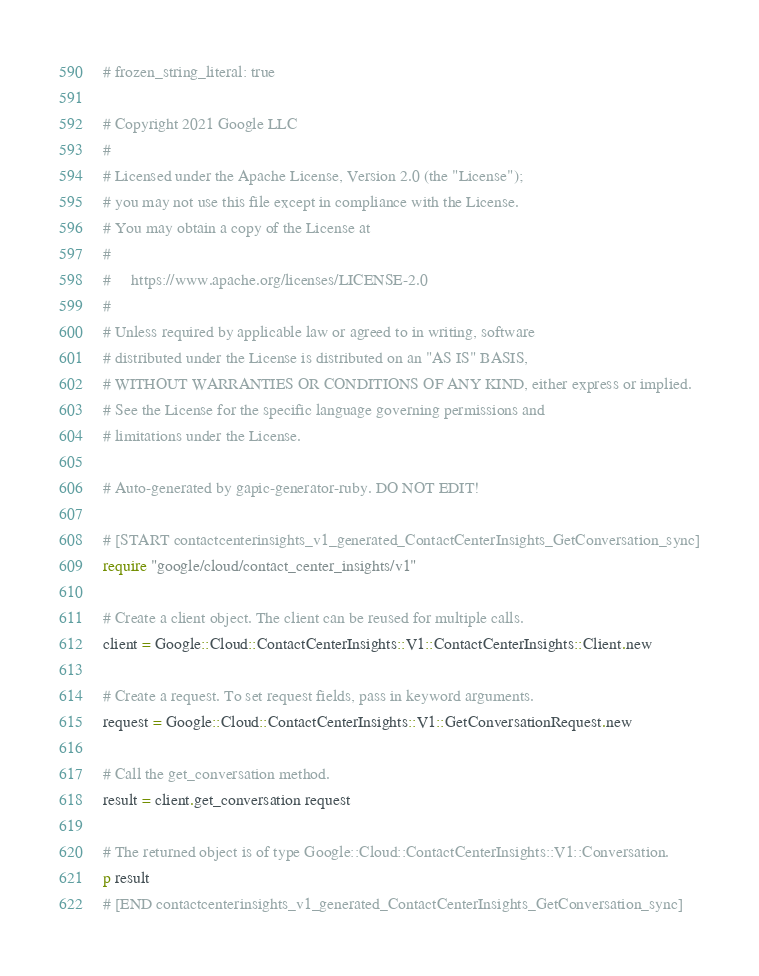<code> <loc_0><loc_0><loc_500><loc_500><_Ruby_># frozen_string_literal: true

# Copyright 2021 Google LLC
#
# Licensed under the Apache License, Version 2.0 (the "License");
# you may not use this file except in compliance with the License.
# You may obtain a copy of the License at
#
#     https://www.apache.org/licenses/LICENSE-2.0
#
# Unless required by applicable law or agreed to in writing, software
# distributed under the License is distributed on an "AS IS" BASIS,
# WITHOUT WARRANTIES OR CONDITIONS OF ANY KIND, either express or implied.
# See the License for the specific language governing permissions and
# limitations under the License.

# Auto-generated by gapic-generator-ruby. DO NOT EDIT!

# [START contactcenterinsights_v1_generated_ContactCenterInsights_GetConversation_sync]
require "google/cloud/contact_center_insights/v1"

# Create a client object. The client can be reused for multiple calls.
client = Google::Cloud::ContactCenterInsights::V1::ContactCenterInsights::Client.new

# Create a request. To set request fields, pass in keyword arguments.
request = Google::Cloud::ContactCenterInsights::V1::GetConversationRequest.new

# Call the get_conversation method.
result = client.get_conversation request

# The returned object is of type Google::Cloud::ContactCenterInsights::V1::Conversation.
p result
# [END contactcenterinsights_v1_generated_ContactCenterInsights_GetConversation_sync]
</code> 